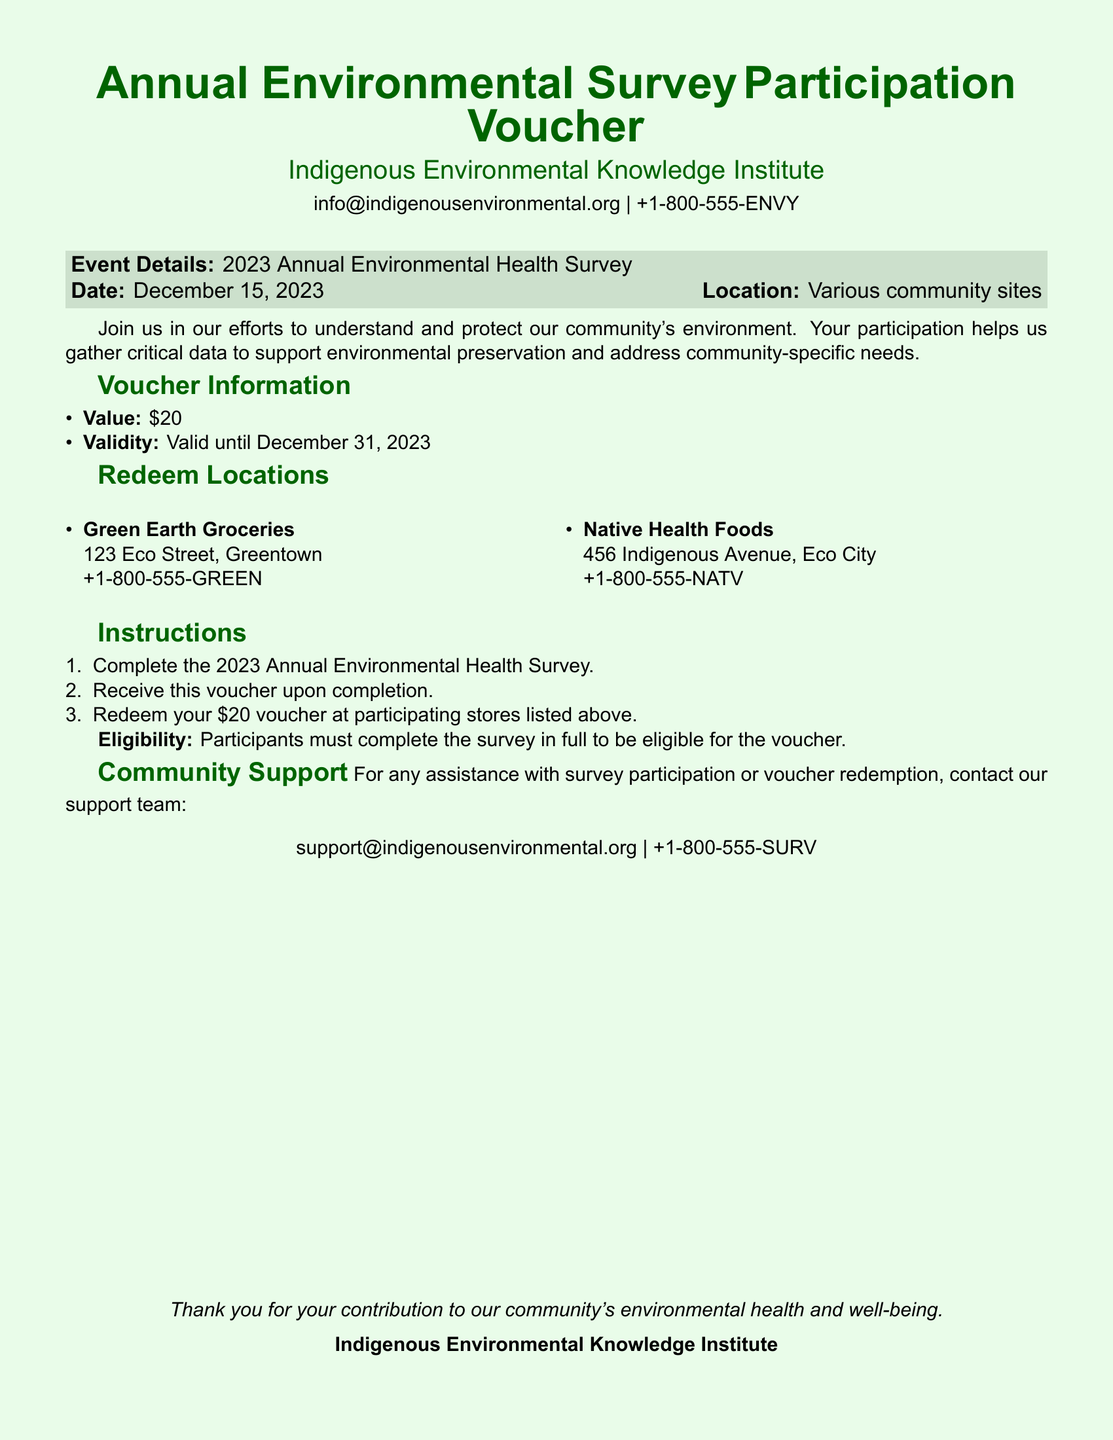What is the event date? The event date is provided in the document under "Event Details" section.
Answer: December 15, 2023 What is the voucher value? The voucher value is stated in the "Voucher Information" section of the document.
Answer: $20 Where can the voucher be redeemed? The "Redeem Locations" section lists the places for voucher redemption.
Answer: Green Earth Groceries, Native Health Foods What is the validity period of the voucher? The validity of the voucher is mentioned in the "Voucher Information" section.
Answer: Valid until December 31, 2023 What must participants do to receive the voucher? To find this out, one needs to look at the "Instructions" section that outlines the steps.
Answer: Complete the survey in full How can participants get support for survey participation? Support details are given under the "Community Support" section with contact information.
Answer: support@indigenousenvironmental.org How many redeem locations are listed? The number of redeem locations is found within the "Redeem Locations" section of the document.
Answer: 2 What kind of data is being gathered from the survey? Understanding the type of data relies on a broader understanding of the document’s purpose stated in the introduction.
Answer: Environmental data Who to contact for assistance with voucher redemption? Assistance contact information is provided in the "Community Support" section.
Answer: +1-800-555-SURV 